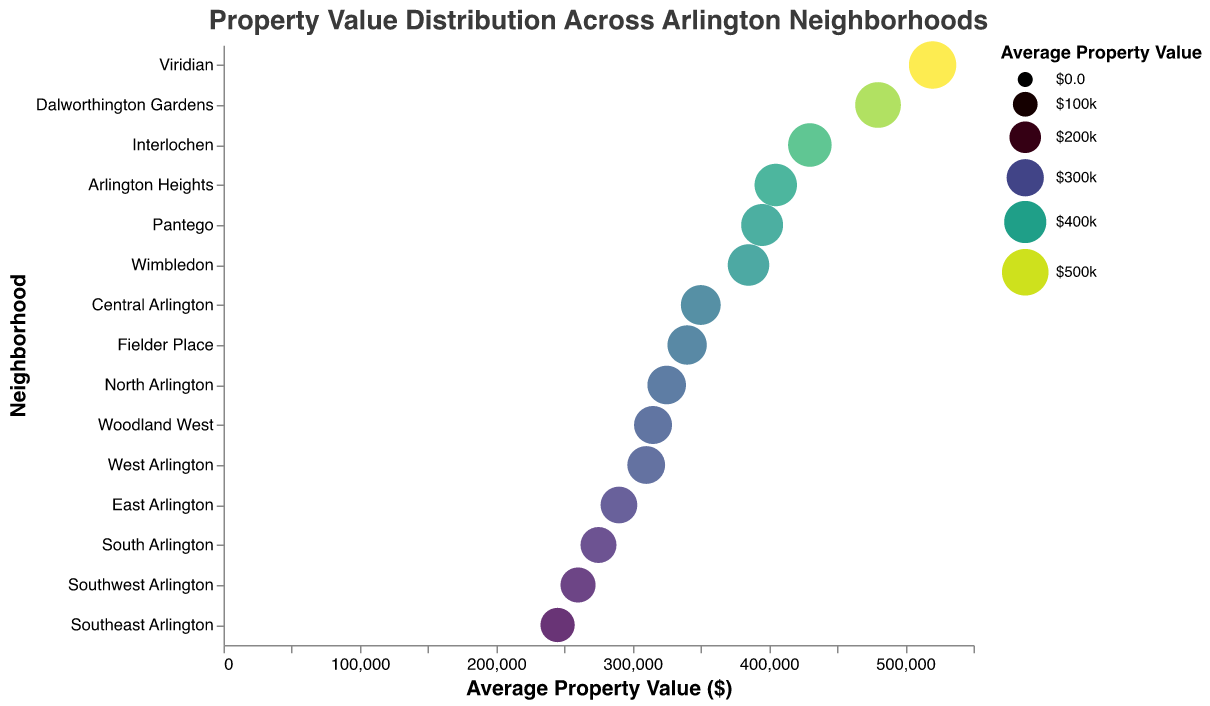What's the title of the figure? The title is written at the top center of the figure. It provides an overview of what the figure is representing.
Answer: Property Value Distribution Across Arlington Neighborhoods How many neighborhoods are displayed in the figure? Count the number of distinct neighborhood names listed on the y-axis of the figure.
Answer: 15 Which neighborhood has the highest average property value? Identify the plot where the bubble representing the average property value is placed furthest along the x-axis.
Answer: Viridian What is the average property value of South Arlington? Locate the bubble representing South Arlington and read the corresponding value from the x-axis or the tooltip.
Answer: $275,000 Which neighborhood has the lowest average property value? Identify the plot where the bubble representing the average property value is placed closest to the origin on the x-axis.
Answer: Southeast Arlington How much higher is the average property value in Interlochen compared to Fielder Place? Find the values for Interlochen and Fielder Place, then subtract Fielder Place's value from Interlochen's value. $430,000 - $340,000 = $90,000
Answer: $90,000 What is the median average property value of all neighborhoods? List all neighborhood values in ascending order: ($245,000, $260,000, $275,000, $290,000, $310,000, $315,000, $325,000, $340,000, $350,000, $385,000, $395,000, $405,000, $430,000, $480,000, $520,000). The middle value in this ordered list is the median.
Answer: $350,000 Which neighborhood has the closest average property value to the median value? Compare each neighborhood's average property value to the median calculated previously ($350,000) and identify the closest one through inspection.
Answer: Central Arlington What is the difference in average property value between Central Arlington and North Arlington? Find the values for Central Arlington and North Arlington, then subtract North Arlington's value from Central Arlington's value. $350,000 - $325,000 = $25,000
Answer: $25,000 Are there any neighborhoods with average property values within $10,000 of $300,000? Look for any bubbles that represent values between $290,000 and $310,000. Specifically check East Arlington and Woodland West.
Answer: Yes, East Arlington and Woodland West 